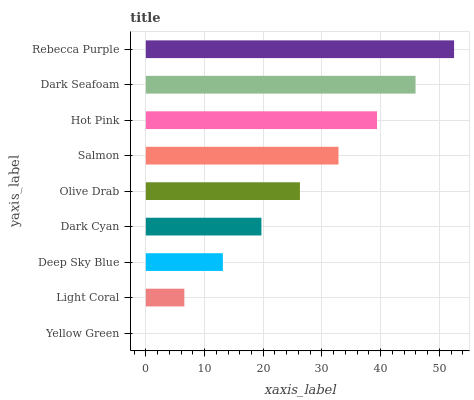Is Yellow Green the minimum?
Answer yes or no. Yes. Is Rebecca Purple the maximum?
Answer yes or no. Yes. Is Light Coral the minimum?
Answer yes or no. No. Is Light Coral the maximum?
Answer yes or no. No. Is Light Coral greater than Yellow Green?
Answer yes or no. Yes. Is Yellow Green less than Light Coral?
Answer yes or no. Yes. Is Yellow Green greater than Light Coral?
Answer yes or no. No. Is Light Coral less than Yellow Green?
Answer yes or no. No. Is Olive Drab the high median?
Answer yes or no. Yes. Is Olive Drab the low median?
Answer yes or no. Yes. Is Dark Seafoam the high median?
Answer yes or no. No. Is Dark Cyan the low median?
Answer yes or no. No. 